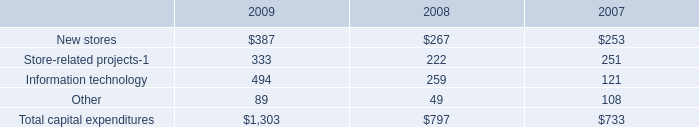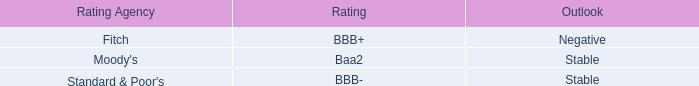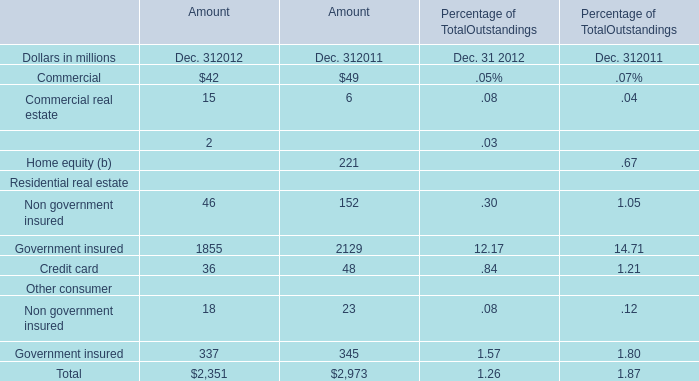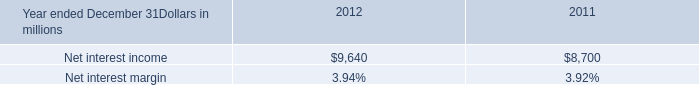what was the percentage change in the non interest income from from 2011 to 2012 
Computations: ((5.9 - 5.6) / 5.6)
Answer: 0.05357. 